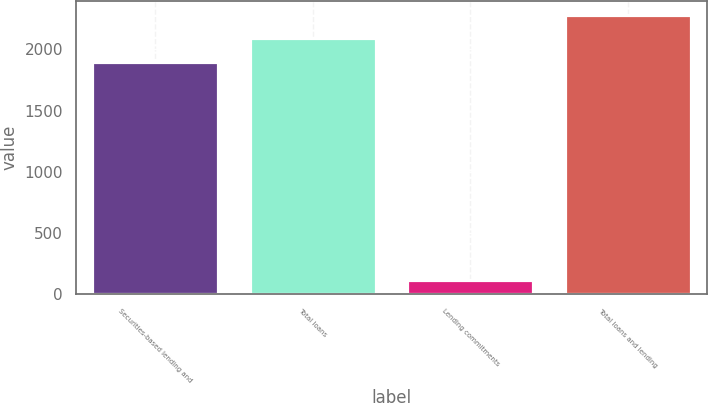Convert chart to OTSL. <chart><loc_0><loc_0><loc_500><loc_500><bar_chart><fcel>Securities-based lending and<fcel>Total loans<fcel>Lending commitments<fcel>Total loans and lending<nl><fcel>1899<fcel>2090.4<fcel>120<fcel>2281.8<nl></chart> 